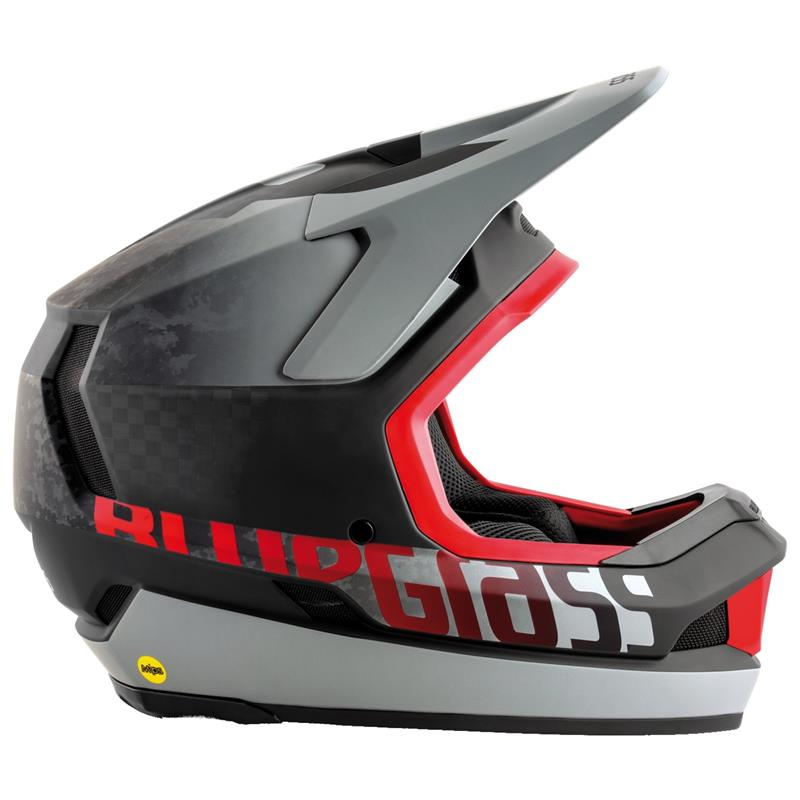Imagine if this helmet had an integrated display for navigation and performance metrics. How might that impact its design and functionality? Integrating a display for navigation and performance metrics into this helmet could revolutionize its design and functionality. The display would likely be seamlessly embedded into the visor or a dedicated heads-up display (HUD) module within the rider's line of sight. This integration could involve the use of transparent OLED or augmented reality (AR) technologies, allowing for real-time data projection without obscuring the rider's vision. Functionally, it would provide GPS navigation, speed, distance, and other performance metrics directly to the rider, reducing the need to look down at separate devices. It might also include features like call notifications, music controls, and emergency alerts. Such a design would necessitate additional considerations for weight distribution, battery life, and waterproofing, ensuring the helmet remains comfortable, safe, and reliable under various conditions. 